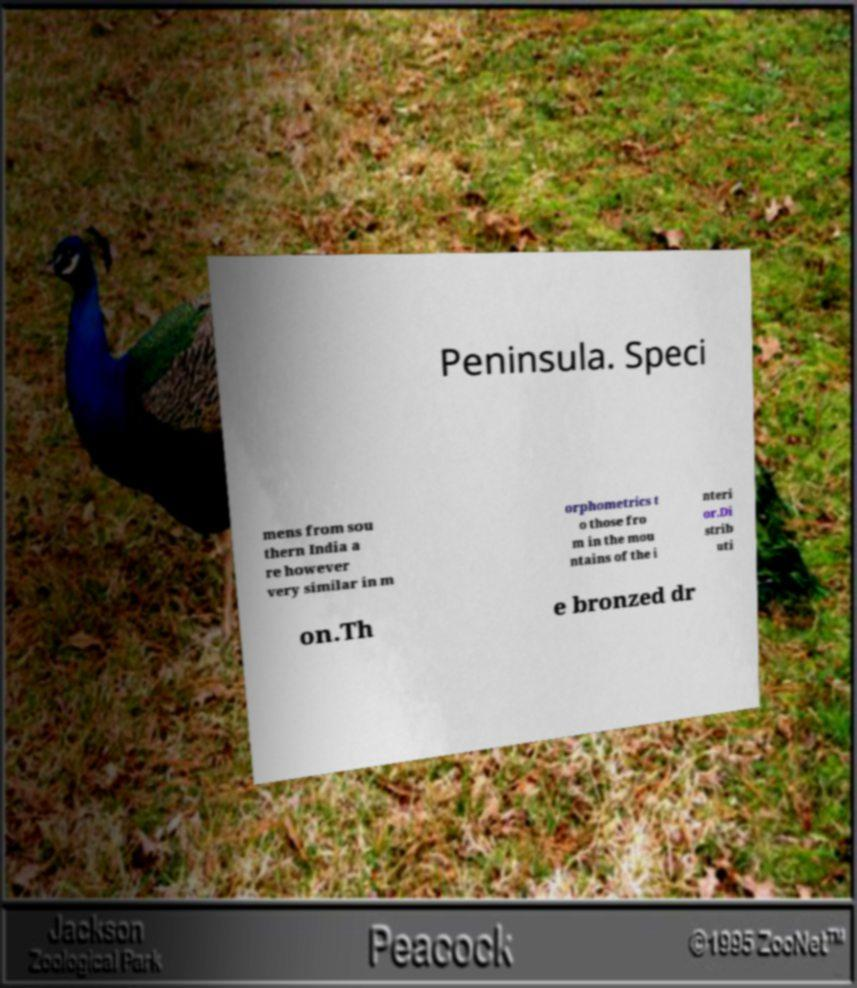Please identify and transcribe the text found in this image. Peninsula. Speci mens from sou thern India a re however very similar in m orphometrics t o those fro m in the mou ntains of the i nteri or.Di strib uti on.Th e bronzed dr 